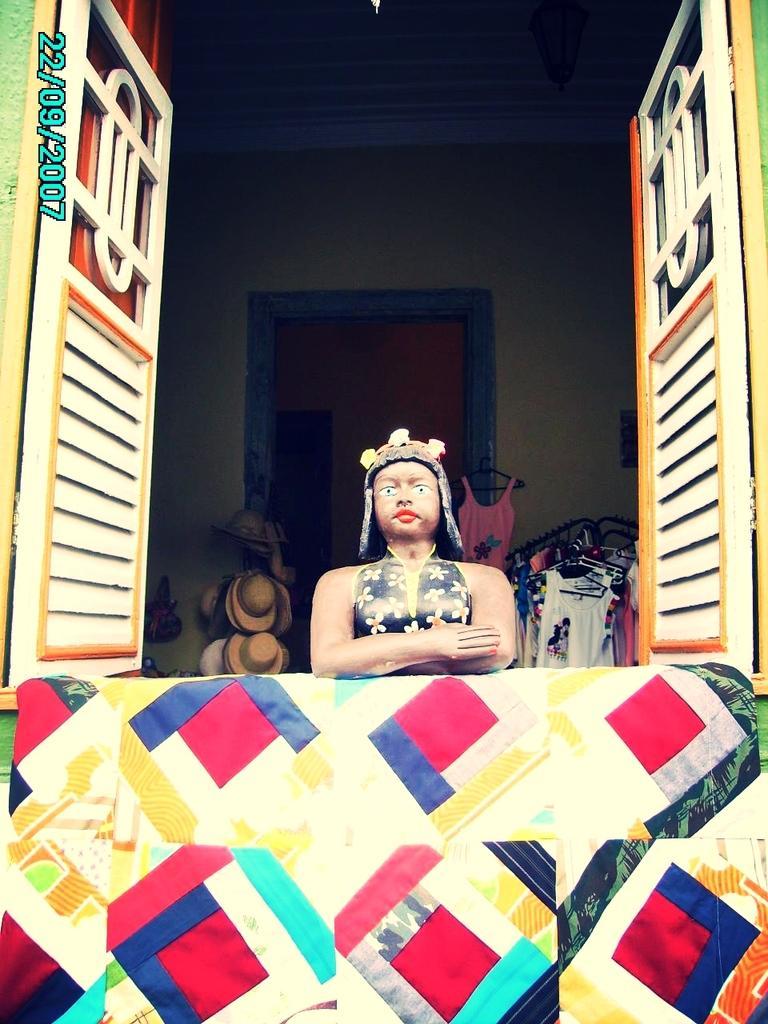Can you describe this image briefly? Here we can see colorful wall,behind this wall we can see statue and window. In the background we can see hats,clothes and wall. 